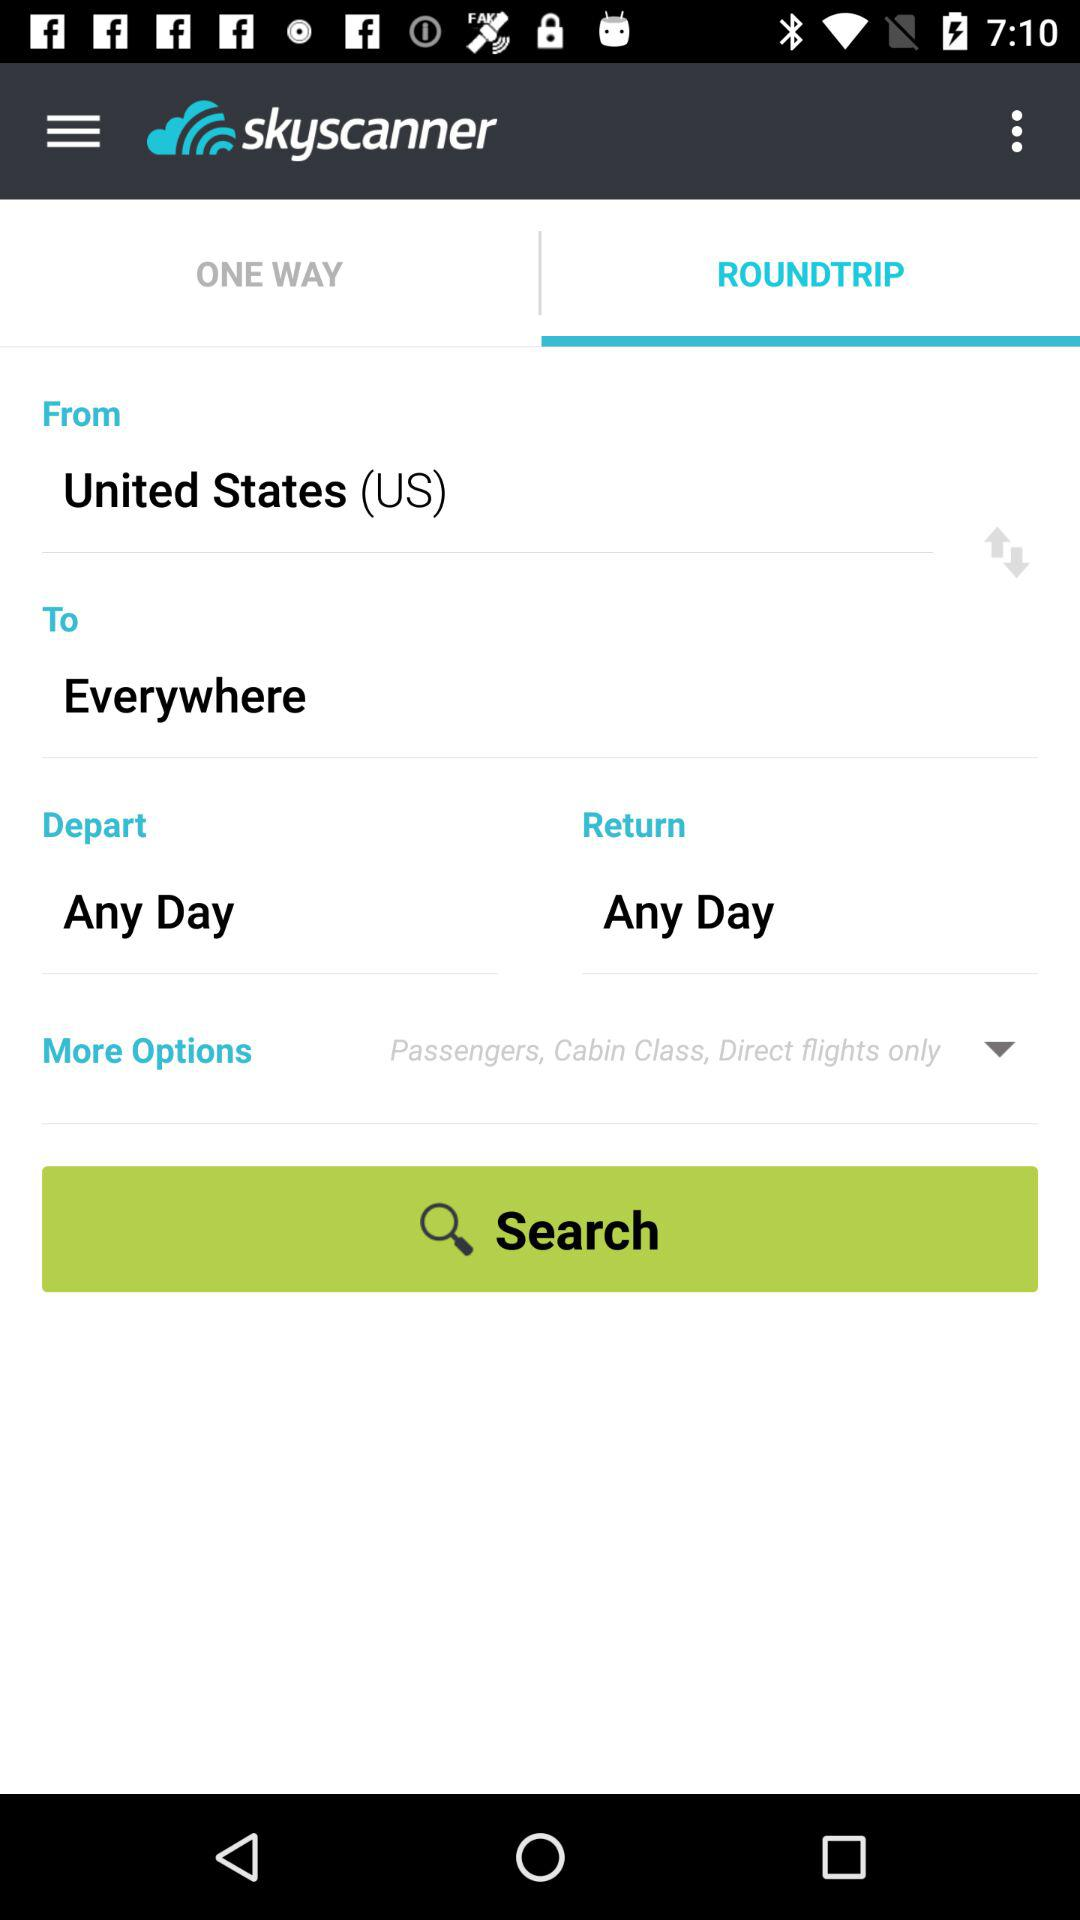What is the application name? The application name is "skyscanner". 